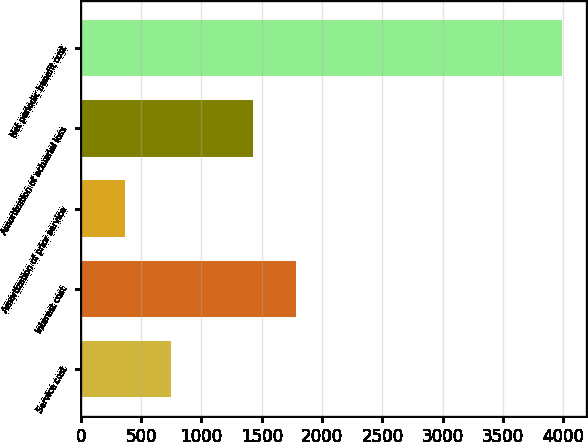Convert chart. <chart><loc_0><loc_0><loc_500><loc_500><bar_chart><fcel>Service cost<fcel>Interest cost<fcel>Amortization of prior service<fcel>Amortization of actuarial loss<fcel>Net periodic benefit cost<nl><fcel>750<fcel>1785.5<fcel>371<fcel>1424<fcel>3986<nl></chart> 